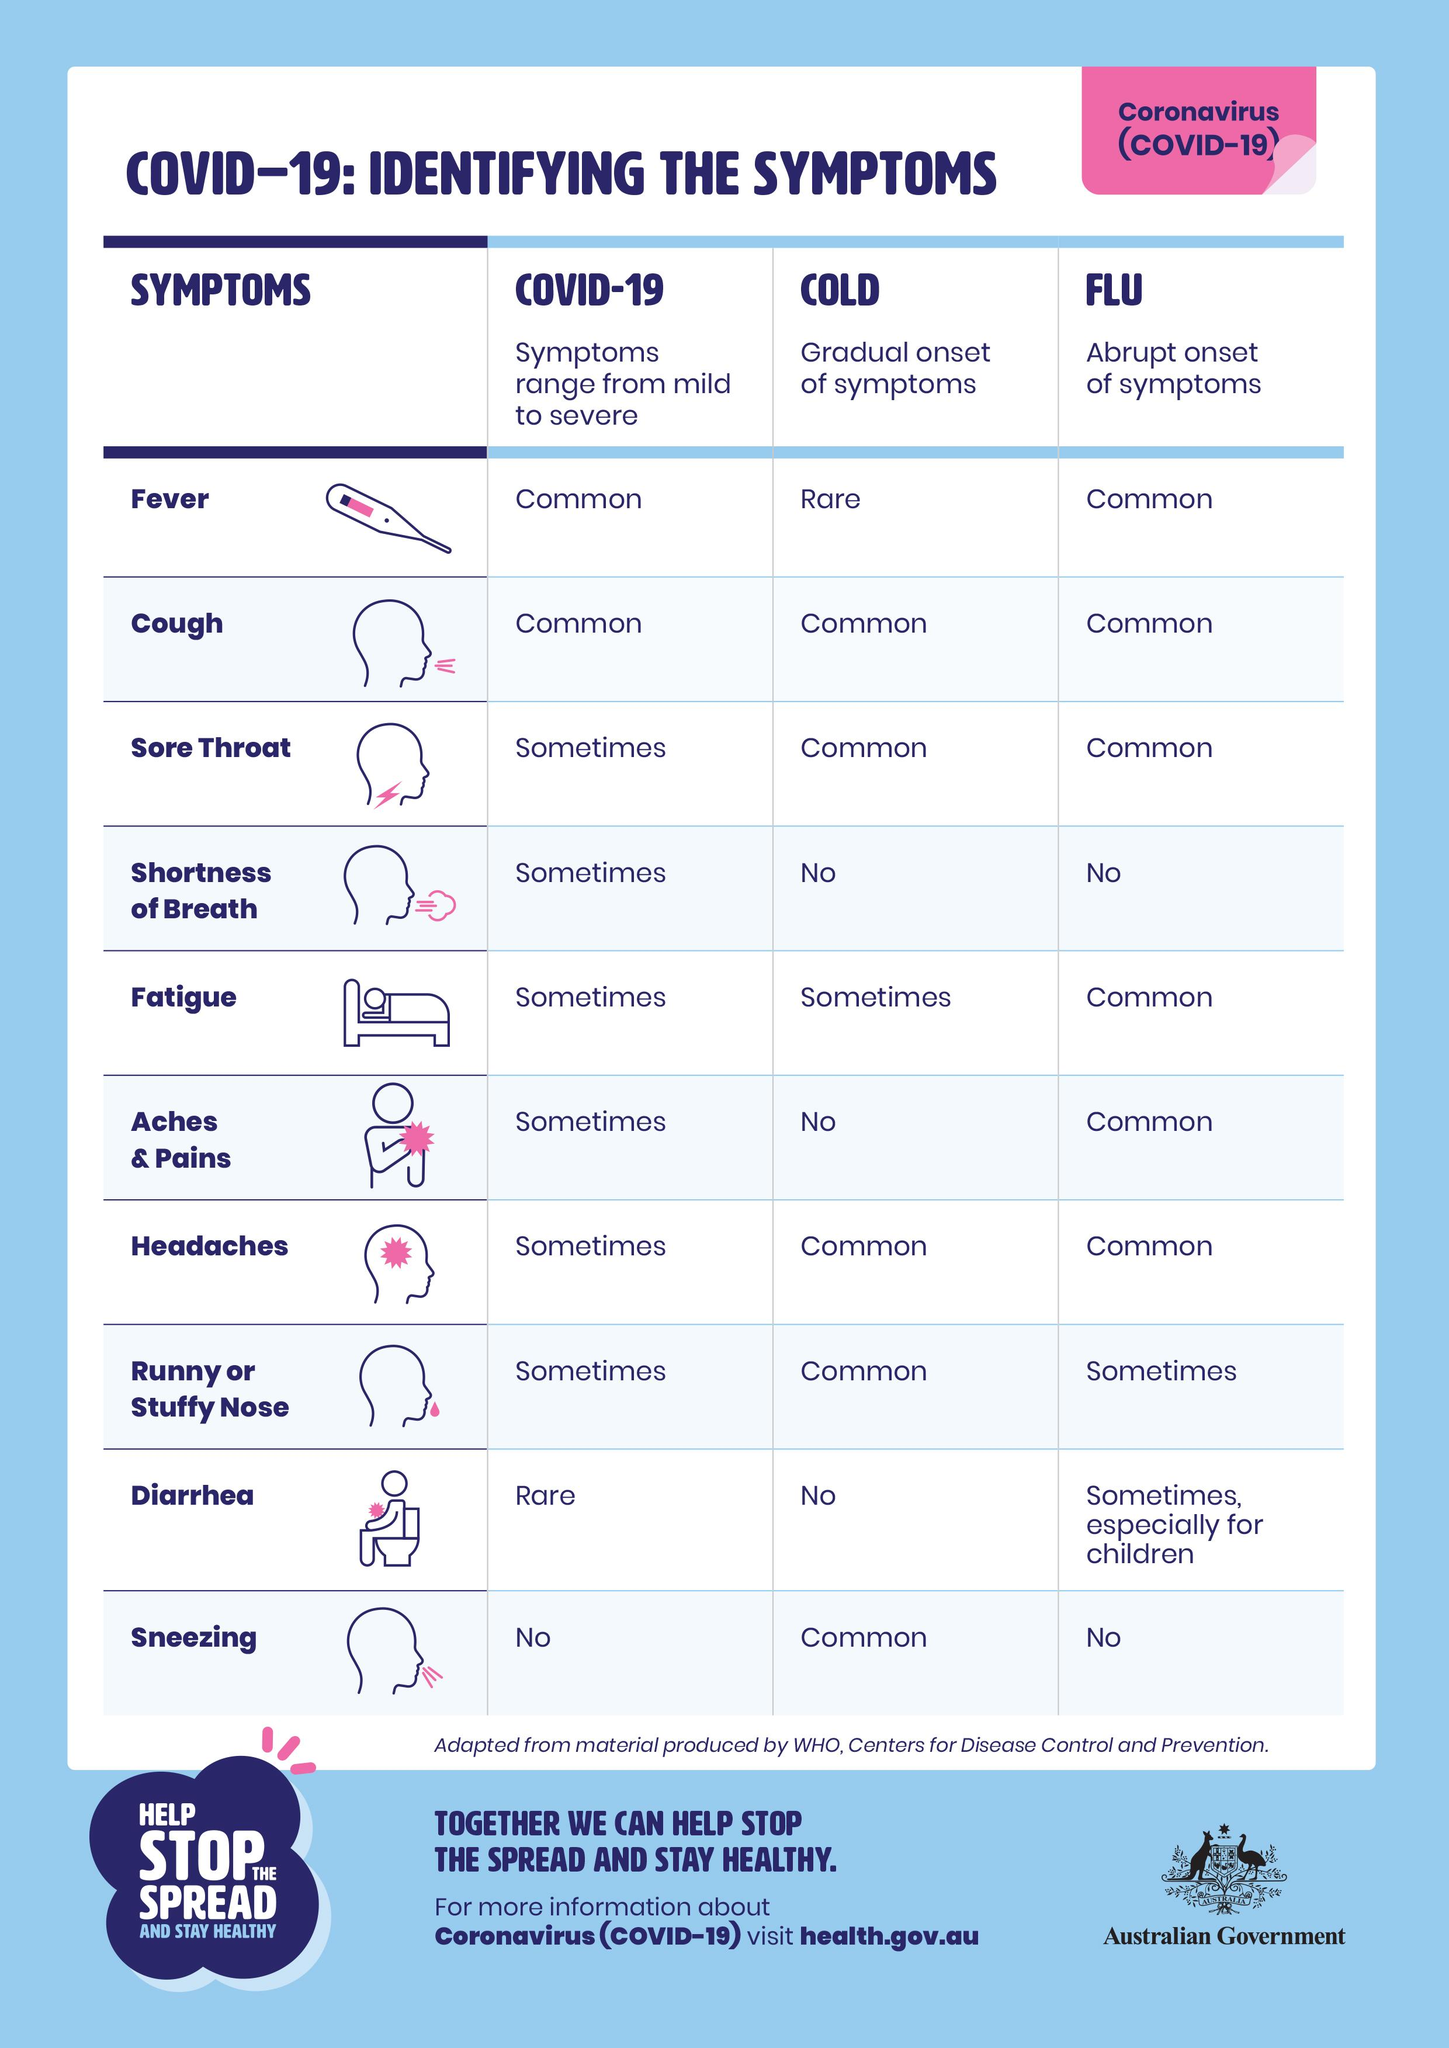Highlight a few significant elements in this photo. Covid-19 is commonly associated with coughing, just as cold and flu are. Diarrhea is considered a very rare symptom of COVID-19. 